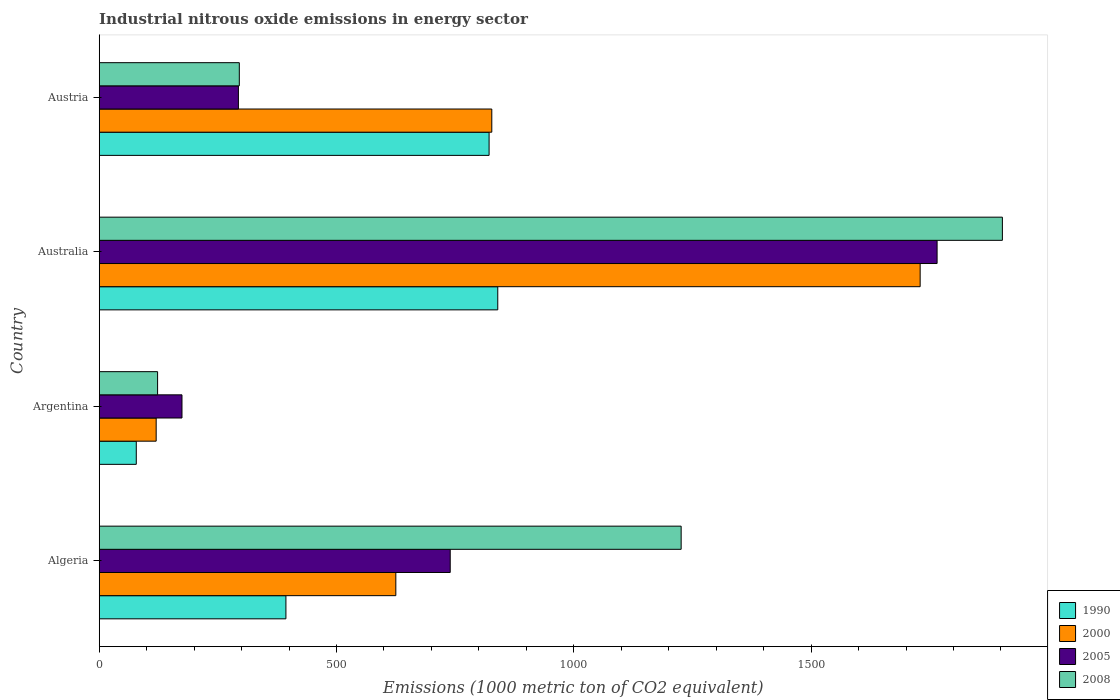How many different coloured bars are there?
Ensure brevity in your answer.  4. How many groups of bars are there?
Provide a short and direct response. 4. Are the number of bars per tick equal to the number of legend labels?
Your answer should be compact. Yes. Are the number of bars on each tick of the Y-axis equal?
Make the answer very short. Yes. How many bars are there on the 2nd tick from the top?
Your response must be concise. 4. How many bars are there on the 2nd tick from the bottom?
Keep it short and to the point. 4. What is the label of the 4th group of bars from the top?
Your answer should be compact. Algeria. What is the amount of industrial nitrous oxide emitted in 2000 in Argentina?
Give a very brief answer. 120. Across all countries, what is the maximum amount of industrial nitrous oxide emitted in 2000?
Make the answer very short. 1729.8. Across all countries, what is the minimum amount of industrial nitrous oxide emitted in 2008?
Your answer should be very brief. 123. In which country was the amount of industrial nitrous oxide emitted in 2000 minimum?
Your answer should be very brief. Argentina. What is the total amount of industrial nitrous oxide emitted in 2005 in the graph?
Ensure brevity in your answer.  2972.8. What is the difference between the amount of industrial nitrous oxide emitted in 2008 in Algeria and that in Argentina?
Provide a succinct answer. 1103.2. What is the difference between the amount of industrial nitrous oxide emitted in 2005 in Austria and the amount of industrial nitrous oxide emitted in 2000 in Algeria?
Provide a short and direct response. -331.7. What is the average amount of industrial nitrous oxide emitted in 1990 per country?
Give a very brief answer. 533.2. What is the difference between the amount of industrial nitrous oxide emitted in 1990 and amount of industrial nitrous oxide emitted in 2005 in Australia?
Provide a succinct answer. -925.7. What is the ratio of the amount of industrial nitrous oxide emitted in 1990 in Algeria to that in Australia?
Ensure brevity in your answer.  0.47. Is the difference between the amount of industrial nitrous oxide emitted in 1990 in Algeria and Australia greater than the difference between the amount of industrial nitrous oxide emitted in 2005 in Algeria and Australia?
Provide a short and direct response. Yes. What is the difference between the highest and the second highest amount of industrial nitrous oxide emitted in 2008?
Provide a succinct answer. 676.9. What is the difference between the highest and the lowest amount of industrial nitrous oxide emitted in 1990?
Offer a very short reply. 761.7. Is it the case that in every country, the sum of the amount of industrial nitrous oxide emitted in 2008 and amount of industrial nitrous oxide emitted in 1990 is greater than the sum of amount of industrial nitrous oxide emitted in 2000 and amount of industrial nitrous oxide emitted in 2005?
Provide a short and direct response. No. What does the 2nd bar from the top in Australia represents?
Offer a very short reply. 2005. What does the 1st bar from the bottom in Austria represents?
Give a very brief answer. 1990. How many bars are there?
Offer a terse response. 16. Are all the bars in the graph horizontal?
Your answer should be compact. Yes. How many countries are there in the graph?
Provide a short and direct response. 4. Does the graph contain any zero values?
Your answer should be very brief. No. Does the graph contain grids?
Provide a short and direct response. No. What is the title of the graph?
Offer a very short reply. Industrial nitrous oxide emissions in energy sector. Does "1974" appear as one of the legend labels in the graph?
Provide a succinct answer. No. What is the label or title of the X-axis?
Offer a very short reply. Emissions (1000 metric ton of CO2 equivalent). What is the Emissions (1000 metric ton of CO2 equivalent) of 1990 in Algeria?
Your response must be concise. 393.4. What is the Emissions (1000 metric ton of CO2 equivalent) in 2000 in Algeria?
Keep it short and to the point. 625. What is the Emissions (1000 metric ton of CO2 equivalent) of 2005 in Algeria?
Your answer should be very brief. 739.6. What is the Emissions (1000 metric ton of CO2 equivalent) in 2008 in Algeria?
Your answer should be very brief. 1226.2. What is the Emissions (1000 metric ton of CO2 equivalent) in 1990 in Argentina?
Your response must be concise. 78.1. What is the Emissions (1000 metric ton of CO2 equivalent) of 2000 in Argentina?
Offer a terse response. 120. What is the Emissions (1000 metric ton of CO2 equivalent) in 2005 in Argentina?
Offer a terse response. 174.4. What is the Emissions (1000 metric ton of CO2 equivalent) of 2008 in Argentina?
Give a very brief answer. 123. What is the Emissions (1000 metric ton of CO2 equivalent) in 1990 in Australia?
Ensure brevity in your answer.  839.8. What is the Emissions (1000 metric ton of CO2 equivalent) in 2000 in Australia?
Make the answer very short. 1729.8. What is the Emissions (1000 metric ton of CO2 equivalent) in 2005 in Australia?
Provide a succinct answer. 1765.5. What is the Emissions (1000 metric ton of CO2 equivalent) of 2008 in Australia?
Keep it short and to the point. 1903.1. What is the Emissions (1000 metric ton of CO2 equivalent) in 1990 in Austria?
Offer a terse response. 821.5. What is the Emissions (1000 metric ton of CO2 equivalent) in 2000 in Austria?
Ensure brevity in your answer.  827.2. What is the Emissions (1000 metric ton of CO2 equivalent) of 2005 in Austria?
Your answer should be very brief. 293.3. What is the Emissions (1000 metric ton of CO2 equivalent) of 2008 in Austria?
Keep it short and to the point. 295.2. Across all countries, what is the maximum Emissions (1000 metric ton of CO2 equivalent) in 1990?
Provide a short and direct response. 839.8. Across all countries, what is the maximum Emissions (1000 metric ton of CO2 equivalent) of 2000?
Offer a very short reply. 1729.8. Across all countries, what is the maximum Emissions (1000 metric ton of CO2 equivalent) in 2005?
Give a very brief answer. 1765.5. Across all countries, what is the maximum Emissions (1000 metric ton of CO2 equivalent) in 2008?
Your answer should be compact. 1903.1. Across all countries, what is the minimum Emissions (1000 metric ton of CO2 equivalent) of 1990?
Offer a terse response. 78.1. Across all countries, what is the minimum Emissions (1000 metric ton of CO2 equivalent) of 2000?
Give a very brief answer. 120. Across all countries, what is the minimum Emissions (1000 metric ton of CO2 equivalent) of 2005?
Give a very brief answer. 174.4. Across all countries, what is the minimum Emissions (1000 metric ton of CO2 equivalent) in 2008?
Offer a terse response. 123. What is the total Emissions (1000 metric ton of CO2 equivalent) of 1990 in the graph?
Your answer should be very brief. 2132.8. What is the total Emissions (1000 metric ton of CO2 equivalent) in 2000 in the graph?
Your answer should be compact. 3302. What is the total Emissions (1000 metric ton of CO2 equivalent) of 2005 in the graph?
Provide a succinct answer. 2972.8. What is the total Emissions (1000 metric ton of CO2 equivalent) in 2008 in the graph?
Your answer should be compact. 3547.5. What is the difference between the Emissions (1000 metric ton of CO2 equivalent) in 1990 in Algeria and that in Argentina?
Offer a terse response. 315.3. What is the difference between the Emissions (1000 metric ton of CO2 equivalent) of 2000 in Algeria and that in Argentina?
Your response must be concise. 505. What is the difference between the Emissions (1000 metric ton of CO2 equivalent) of 2005 in Algeria and that in Argentina?
Provide a succinct answer. 565.2. What is the difference between the Emissions (1000 metric ton of CO2 equivalent) of 2008 in Algeria and that in Argentina?
Your answer should be very brief. 1103.2. What is the difference between the Emissions (1000 metric ton of CO2 equivalent) of 1990 in Algeria and that in Australia?
Keep it short and to the point. -446.4. What is the difference between the Emissions (1000 metric ton of CO2 equivalent) of 2000 in Algeria and that in Australia?
Provide a succinct answer. -1104.8. What is the difference between the Emissions (1000 metric ton of CO2 equivalent) of 2005 in Algeria and that in Australia?
Provide a succinct answer. -1025.9. What is the difference between the Emissions (1000 metric ton of CO2 equivalent) in 2008 in Algeria and that in Australia?
Your answer should be very brief. -676.9. What is the difference between the Emissions (1000 metric ton of CO2 equivalent) of 1990 in Algeria and that in Austria?
Your response must be concise. -428.1. What is the difference between the Emissions (1000 metric ton of CO2 equivalent) of 2000 in Algeria and that in Austria?
Ensure brevity in your answer.  -202.2. What is the difference between the Emissions (1000 metric ton of CO2 equivalent) of 2005 in Algeria and that in Austria?
Your answer should be very brief. 446.3. What is the difference between the Emissions (1000 metric ton of CO2 equivalent) of 2008 in Algeria and that in Austria?
Keep it short and to the point. 931. What is the difference between the Emissions (1000 metric ton of CO2 equivalent) of 1990 in Argentina and that in Australia?
Ensure brevity in your answer.  -761.7. What is the difference between the Emissions (1000 metric ton of CO2 equivalent) in 2000 in Argentina and that in Australia?
Give a very brief answer. -1609.8. What is the difference between the Emissions (1000 metric ton of CO2 equivalent) of 2005 in Argentina and that in Australia?
Keep it short and to the point. -1591.1. What is the difference between the Emissions (1000 metric ton of CO2 equivalent) of 2008 in Argentina and that in Australia?
Provide a succinct answer. -1780.1. What is the difference between the Emissions (1000 metric ton of CO2 equivalent) in 1990 in Argentina and that in Austria?
Offer a terse response. -743.4. What is the difference between the Emissions (1000 metric ton of CO2 equivalent) in 2000 in Argentina and that in Austria?
Provide a succinct answer. -707.2. What is the difference between the Emissions (1000 metric ton of CO2 equivalent) in 2005 in Argentina and that in Austria?
Provide a short and direct response. -118.9. What is the difference between the Emissions (1000 metric ton of CO2 equivalent) of 2008 in Argentina and that in Austria?
Your response must be concise. -172.2. What is the difference between the Emissions (1000 metric ton of CO2 equivalent) of 2000 in Australia and that in Austria?
Your answer should be very brief. 902.6. What is the difference between the Emissions (1000 metric ton of CO2 equivalent) in 2005 in Australia and that in Austria?
Your response must be concise. 1472.2. What is the difference between the Emissions (1000 metric ton of CO2 equivalent) in 2008 in Australia and that in Austria?
Offer a terse response. 1607.9. What is the difference between the Emissions (1000 metric ton of CO2 equivalent) in 1990 in Algeria and the Emissions (1000 metric ton of CO2 equivalent) in 2000 in Argentina?
Give a very brief answer. 273.4. What is the difference between the Emissions (1000 metric ton of CO2 equivalent) in 1990 in Algeria and the Emissions (1000 metric ton of CO2 equivalent) in 2005 in Argentina?
Offer a very short reply. 219. What is the difference between the Emissions (1000 metric ton of CO2 equivalent) of 1990 in Algeria and the Emissions (1000 metric ton of CO2 equivalent) of 2008 in Argentina?
Your answer should be very brief. 270.4. What is the difference between the Emissions (1000 metric ton of CO2 equivalent) of 2000 in Algeria and the Emissions (1000 metric ton of CO2 equivalent) of 2005 in Argentina?
Your response must be concise. 450.6. What is the difference between the Emissions (1000 metric ton of CO2 equivalent) in 2000 in Algeria and the Emissions (1000 metric ton of CO2 equivalent) in 2008 in Argentina?
Offer a very short reply. 502. What is the difference between the Emissions (1000 metric ton of CO2 equivalent) in 2005 in Algeria and the Emissions (1000 metric ton of CO2 equivalent) in 2008 in Argentina?
Offer a very short reply. 616.6. What is the difference between the Emissions (1000 metric ton of CO2 equivalent) in 1990 in Algeria and the Emissions (1000 metric ton of CO2 equivalent) in 2000 in Australia?
Provide a short and direct response. -1336.4. What is the difference between the Emissions (1000 metric ton of CO2 equivalent) of 1990 in Algeria and the Emissions (1000 metric ton of CO2 equivalent) of 2005 in Australia?
Your response must be concise. -1372.1. What is the difference between the Emissions (1000 metric ton of CO2 equivalent) of 1990 in Algeria and the Emissions (1000 metric ton of CO2 equivalent) of 2008 in Australia?
Provide a succinct answer. -1509.7. What is the difference between the Emissions (1000 metric ton of CO2 equivalent) of 2000 in Algeria and the Emissions (1000 metric ton of CO2 equivalent) of 2005 in Australia?
Make the answer very short. -1140.5. What is the difference between the Emissions (1000 metric ton of CO2 equivalent) in 2000 in Algeria and the Emissions (1000 metric ton of CO2 equivalent) in 2008 in Australia?
Offer a terse response. -1278.1. What is the difference between the Emissions (1000 metric ton of CO2 equivalent) of 2005 in Algeria and the Emissions (1000 metric ton of CO2 equivalent) of 2008 in Australia?
Your response must be concise. -1163.5. What is the difference between the Emissions (1000 metric ton of CO2 equivalent) of 1990 in Algeria and the Emissions (1000 metric ton of CO2 equivalent) of 2000 in Austria?
Your answer should be compact. -433.8. What is the difference between the Emissions (1000 metric ton of CO2 equivalent) in 1990 in Algeria and the Emissions (1000 metric ton of CO2 equivalent) in 2005 in Austria?
Keep it short and to the point. 100.1. What is the difference between the Emissions (1000 metric ton of CO2 equivalent) in 1990 in Algeria and the Emissions (1000 metric ton of CO2 equivalent) in 2008 in Austria?
Offer a terse response. 98.2. What is the difference between the Emissions (1000 metric ton of CO2 equivalent) in 2000 in Algeria and the Emissions (1000 metric ton of CO2 equivalent) in 2005 in Austria?
Provide a short and direct response. 331.7. What is the difference between the Emissions (1000 metric ton of CO2 equivalent) in 2000 in Algeria and the Emissions (1000 metric ton of CO2 equivalent) in 2008 in Austria?
Give a very brief answer. 329.8. What is the difference between the Emissions (1000 metric ton of CO2 equivalent) of 2005 in Algeria and the Emissions (1000 metric ton of CO2 equivalent) of 2008 in Austria?
Provide a short and direct response. 444.4. What is the difference between the Emissions (1000 metric ton of CO2 equivalent) of 1990 in Argentina and the Emissions (1000 metric ton of CO2 equivalent) of 2000 in Australia?
Provide a succinct answer. -1651.7. What is the difference between the Emissions (1000 metric ton of CO2 equivalent) of 1990 in Argentina and the Emissions (1000 metric ton of CO2 equivalent) of 2005 in Australia?
Your response must be concise. -1687.4. What is the difference between the Emissions (1000 metric ton of CO2 equivalent) of 1990 in Argentina and the Emissions (1000 metric ton of CO2 equivalent) of 2008 in Australia?
Your answer should be compact. -1825. What is the difference between the Emissions (1000 metric ton of CO2 equivalent) of 2000 in Argentina and the Emissions (1000 metric ton of CO2 equivalent) of 2005 in Australia?
Ensure brevity in your answer.  -1645.5. What is the difference between the Emissions (1000 metric ton of CO2 equivalent) in 2000 in Argentina and the Emissions (1000 metric ton of CO2 equivalent) in 2008 in Australia?
Make the answer very short. -1783.1. What is the difference between the Emissions (1000 metric ton of CO2 equivalent) in 2005 in Argentina and the Emissions (1000 metric ton of CO2 equivalent) in 2008 in Australia?
Keep it short and to the point. -1728.7. What is the difference between the Emissions (1000 metric ton of CO2 equivalent) of 1990 in Argentina and the Emissions (1000 metric ton of CO2 equivalent) of 2000 in Austria?
Make the answer very short. -749.1. What is the difference between the Emissions (1000 metric ton of CO2 equivalent) in 1990 in Argentina and the Emissions (1000 metric ton of CO2 equivalent) in 2005 in Austria?
Give a very brief answer. -215.2. What is the difference between the Emissions (1000 metric ton of CO2 equivalent) of 1990 in Argentina and the Emissions (1000 metric ton of CO2 equivalent) of 2008 in Austria?
Make the answer very short. -217.1. What is the difference between the Emissions (1000 metric ton of CO2 equivalent) in 2000 in Argentina and the Emissions (1000 metric ton of CO2 equivalent) in 2005 in Austria?
Keep it short and to the point. -173.3. What is the difference between the Emissions (1000 metric ton of CO2 equivalent) in 2000 in Argentina and the Emissions (1000 metric ton of CO2 equivalent) in 2008 in Austria?
Offer a very short reply. -175.2. What is the difference between the Emissions (1000 metric ton of CO2 equivalent) of 2005 in Argentina and the Emissions (1000 metric ton of CO2 equivalent) of 2008 in Austria?
Offer a terse response. -120.8. What is the difference between the Emissions (1000 metric ton of CO2 equivalent) of 1990 in Australia and the Emissions (1000 metric ton of CO2 equivalent) of 2000 in Austria?
Make the answer very short. 12.6. What is the difference between the Emissions (1000 metric ton of CO2 equivalent) of 1990 in Australia and the Emissions (1000 metric ton of CO2 equivalent) of 2005 in Austria?
Your response must be concise. 546.5. What is the difference between the Emissions (1000 metric ton of CO2 equivalent) of 1990 in Australia and the Emissions (1000 metric ton of CO2 equivalent) of 2008 in Austria?
Your answer should be compact. 544.6. What is the difference between the Emissions (1000 metric ton of CO2 equivalent) in 2000 in Australia and the Emissions (1000 metric ton of CO2 equivalent) in 2005 in Austria?
Ensure brevity in your answer.  1436.5. What is the difference between the Emissions (1000 metric ton of CO2 equivalent) in 2000 in Australia and the Emissions (1000 metric ton of CO2 equivalent) in 2008 in Austria?
Provide a succinct answer. 1434.6. What is the difference between the Emissions (1000 metric ton of CO2 equivalent) in 2005 in Australia and the Emissions (1000 metric ton of CO2 equivalent) in 2008 in Austria?
Your response must be concise. 1470.3. What is the average Emissions (1000 metric ton of CO2 equivalent) in 1990 per country?
Offer a terse response. 533.2. What is the average Emissions (1000 metric ton of CO2 equivalent) in 2000 per country?
Your response must be concise. 825.5. What is the average Emissions (1000 metric ton of CO2 equivalent) of 2005 per country?
Give a very brief answer. 743.2. What is the average Emissions (1000 metric ton of CO2 equivalent) of 2008 per country?
Offer a very short reply. 886.88. What is the difference between the Emissions (1000 metric ton of CO2 equivalent) of 1990 and Emissions (1000 metric ton of CO2 equivalent) of 2000 in Algeria?
Offer a very short reply. -231.6. What is the difference between the Emissions (1000 metric ton of CO2 equivalent) of 1990 and Emissions (1000 metric ton of CO2 equivalent) of 2005 in Algeria?
Your answer should be compact. -346.2. What is the difference between the Emissions (1000 metric ton of CO2 equivalent) of 1990 and Emissions (1000 metric ton of CO2 equivalent) of 2008 in Algeria?
Offer a very short reply. -832.8. What is the difference between the Emissions (1000 metric ton of CO2 equivalent) in 2000 and Emissions (1000 metric ton of CO2 equivalent) in 2005 in Algeria?
Your answer should be very brief. -114.6. What is the difference between the Emissions (1000 metric ton of CO2 equivalent) of 2000 and Emissions (1000 metric ton of CO2 equivalent) of 2008 in Algeria?
Offer a terse response. -601.2. What is the difference between the Emissions (1000 metric ton of CO2 equivalent) of 2005 and Emissions (1000 metric ton of CO2 equivalent) of 2008 in Algeria?
Offer a very short reply. -486.6. What is the difference between the Emissions (1000 metric ton of CO2 equivalent) in 1990 and Emissions (1000 metric ton of CO2 equivalent) in 2000 in Argentina?
Offer a very short reply. -41.9. What is the difference between the Emissions (1000 metric ton of CO2 equivalent) in 1990 and Emissions (1000 metric ton of CO2 equivalent) in 2005 in Argentina?
Offer a terse response. -96.3. What is the difference between the Emissions (1000 metric ton of CO2 equivalent) in 1990 and Emissions (1000 metric ton of CO2 equivalent) in 2008 in Argentina?
Your answer should be compact. -44.9. What is the difference between the Emissions (1000 metric ton of CO2 equivalent) of 2000 and Emissions (1000 metric ton of CO2 equivalent) of 2005 in Argentina?
Provide a succinct answer. -54.4. What is the difference between the Emissions (1000 metric ton of CO2 equivalent) of 2005 and Emissions (1000 metric ton of CO2 equivalent) of 2008 in Argentina?
Your answer should be very brief. 51.4. What is the difference between the Emissions (1000 metric ton of CO2 equivalent) in 1990 and Emissions (1000 metric ton of CO2 equivalent) in 2000 in Australia?
Your response must be concise. -890. What is the difference between the Emissions (1000 metric ton of CO2 equivalent) in 1990 and Emissions (1000 metric ton of CO2 equivalent) in 2005 in Australia?
Offer a very short reply. -925.7. What is the difference between the Emissions (1000 metric ton of CO2 equivalent) of 1990 and Emissions (1000 metric ton of CO2 equivalent) of 2008 in Australia?
Make the answer very short. -1063.3. What is the difference between the Emissions (1000 metric ton of CO2 equivalent) in 2000 and Emissions (1000 metric ton of CO2 equivalent) in 2005 in Australia?
Your answer should be very brief. -35.7. What is the difference between the Emissions (1000 metric ton of CO2 equivalent) of 2000 and Emissions (1000 metric ton of CO2 equivalent) of 2008 in Australia?
Your response must be concise. -173.3. What is the difference between the Emissions (1000 metric ton of CO2 equivalent) in 2005 and Emissions (1000 metric ton of CO2 equivalent) in 2008 in Australia?
Ensure brevity in your answer.  -137.6. What is the difference between the Emissions (1000 metric ton of CO2 equivalent) in 1990 and Emissions (1000 metric ton of CO2 equivalent) in 2000 in Austria?
Provide a short and direct response. -5.7. What is the difference between the Emissions (1000 metric ton of CO2 equivalent) in 1990 and Emissions (1000 metric ton of CO2 equivalent) in 2005 in Austria?
Provide a short and direct response. 528.2. What is the difference between the Emissions (1000 metric ton of CO2 equivalent) in 1990 and Emissions (1000 metric ton of CO2 equivalent) in 2008 in Austria?
Make the answer very short. 526.3. What is the difference between the Emissions (1000 metric ton of CO2 equivalent) of 2000 and Emissions (1000 metric ton of CO2 equivalent) of 2005 in Austria?
Your answer should be compact. 533.9. What is the difference between the Emissions (1000 metric ton of CO2 equivalent) in 2000 and Emissions (1000 metric ton of CO2 equivalent) in 2008 in Austria?
Offer a very short reply. 532. What is the ratio of the Emissions (1000 metric ton of CO2 equivalent) in 1990 in Algeria to that in Argentina?
Your answer should be very brief. 5.04. What is the ratio of the Emissions (1000 metric ton of CO2 equivalent) in 2000 in Algeria to that in Argentina?
Keep it short and to the point. 5.21. What is the ratio of the Emissions (1000 metric ton of CO2 equivalent) in 2005 in Algeria to that in Argentina?
Ensure brevity in your answer.  4.24. What is the ratio of the Emissions (1000 metric ton of CO2 equivalent) of 2008 in Algeria to that in Argentina?
Offer a terse response. 9.97. What is the ratio of the Emissions (1000 metric ton of CO2 equivalent) in 1990 in Algeria to that in Australia?
Offer a very short reply. 0.47. What is the ratio of the Emissions (1000 metric ton of CO2 equivalent) of 2000 in Algeria to that in Australia?
Your response must be concise. 0.36. What is the ratio of the Emissions (1000 metric ton of CO2 equivalent) in 2005 in Algeria to that in Australia?
Keep it short and to the point. 0.42. What is the ratio of the Emissions (1000 metric ton of CO2 equivalent) of 2008 in Algeria to that in Australia?
Provide a short and direct response. 0.64. What is the ratio of the Emissions (1000 metric ton of CO2 equivalent) in 1990 in Algeria to that in Austria?
Offer a very short reply. 0.48. What is the ratio of the Emissions (1000 metric ton of CO2 equivalent) in 2000 in Algeria to that in Austria?
Your response must be concise. 0.76. What is the ratio of the Emissions (1000 metric ton of CO2 equivalent) in 2005 in Algeria to that in Austria?
Your response must be concise. 2.52. What is the ratio of the Emissions (1000 metric ton of CO2 equivalent) in 2008 in Algeria to that in Austria?
Ensure brevity in your answer.  4.15. What is the ratio of the Emissions (1000 metric ton of CO2 equivalent) of 1990 in Argentina to that in Australia?
Your answer should be very brief. 0.09. What is the ratio of the Emissions (1000 metric ton of CO2 equivalent) in 2000 in Argentina to that in Australia?
Give a very brief answer. 0.07. What is the ratio of the Emissions (1000 metric ton of CO2 equivalent) in 2005 in Argentina to that in Australia?
Offer a terse response. 0.1. What is the ratio of the Emissions (1000 metric ton of CO2 equivalent) of 2008 in Argentina to that in Australia?
Your response must be concise. 0.06. What is the ratio of the Emissions (1000 metric ton of CO2 equivalent) in 1990 in Argentina to that in Austria?
Keep it short and to the point. 0.1. What is the ratio of the Emissions (1000 metric ton of CO2 equivalent) of 2000 in Argentina to that in Austria?
Give a very brief answer. 0.15. What is the ratio of the Emissions (1000 metric ton of CO2 equivalent) of 2005 in Argentina to that in Austria?
Make the answer very short. 0.59. What is the ratio of the Emissions (1000 metric ton of CO2 equivalent) in 2008 in Argentina to that in Austria?
Provide a short and direct response. 0.42. What is the ratio of the Emissions (1000 metric ton of CO2 equivalent) in 1990 in Australia to that in Austria?
Your response must be concise. 1.02. What is the ratio of the Emissions (1000 metric ton of CO2 equivalent) of 2000 in Australia to that in Austria?
Offer a very short reply. 2.09. What is the ratio of the Emissions (1000 metric ton of CO2 equivalent) in 2005 in Australia to that in Austria?
Make the answer very short. 6.02. What is the ratio of the Emissions (1000 metric ton of CO2 equivalent) in 2008 in Australia to that in Austria?
Provide a short and direct response. 6.45. What is the difference between the highest and the second highest Emissions (1000 metric ton of CO2 equivalent) in 1990?
Offer a terse response. 18.3. What is the difference between the highest and the second highest Emissions (1000 metric ton of CO2 equivalent) of 2000?
Provide a succinct answer. 902.6. What is the difference between the highest and the second highest Emissions (1000 metric ton of CO2 equivalent) in 2005?
Provide a short and direct response. 1025.9. What is the difference between the highest and the second highest Emissions (1000 metric ton of CO2 equivalent) in 2008?
Offer a very short reply. 676.9. What is the difference between the highest and the lowest Emissions (1000 metric ton of CO2 equivalent) of 1990?
Offer a very short reply. 761.7. What is the difference between the highest and the lowest Emissions (1000 metric ton of CO2 equivalent) of 2000?
Your answer should be compact. 1609.8. What is the difference between the highest and the lowest Emissions (1000 metric ton of CO2 equivalent) in 2005?
Your answer should be compact. 1591.1. What is the difference between the highest and the lowest Emissions (1000 metric ton of CO2 equivalent) of 2008?
Your response must be concise. 1780.1. 